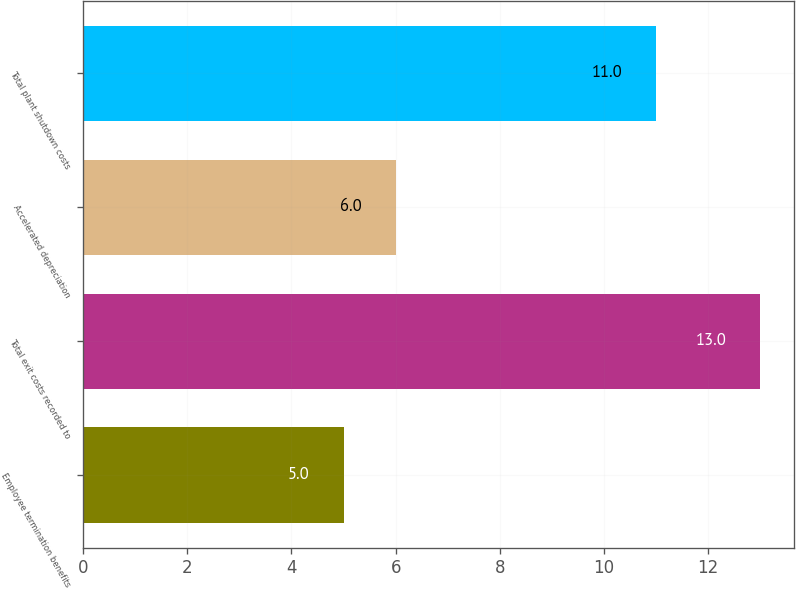<chart> <loc_0><loc_0><loc_500><loc_500><bar_chart><fcel>Employee termination benefits<fcel>Total exit costs recorded to<fcel>Accelerated depreciation<fcel>Total plant shutdown costs<nl><fcel>5<fcel>13<fcel>6<fcel>11<nl></chart> 